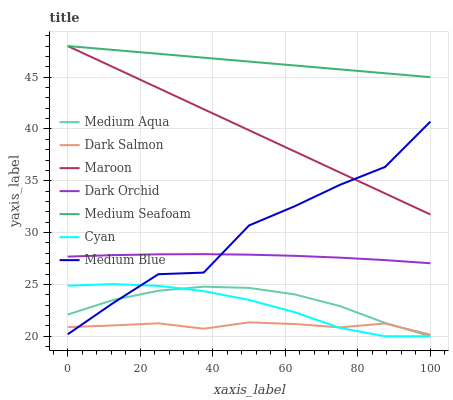Does Dark Salmon have the minimum area under the curve?
Answer yes or no. Yes. Does Medium Seafoam have the maximum area under the curve?
Answer yes or no. Yes. Does Dark Orchid have the minimum area under the curve?
Answer yes or no. No. Does Dark Orchid have the maximum area under the curve?
Answer yes or no. No. Is Medium Seafoam the smoothest?
Answer yes or no. Yes. Is Medium Blue the roughest?
Answer yes or no. Yes. Is Dark Salmon the smoothest?
Answer yes or no. No. Is Dark Salmon the roughest?
Answer yes or no. No. Does Medium Aqua have the lowest value?
Answer yes or no. Yes. Does Dark Salmon have the lowest value?
Answer yes or no. No. Does Medium Seafoam have the highest value?
Answer yes or no. Yes. Does Dark Orchid have the highest value?
Answer yes or no. No. Is Cyan less than Dark Orchid?
Answer yes or no. Yes. Is Dark Orchid greater than Cyan?
Answer yes or no. Yes. Does Medium Blue intersect Dark Orchid?
Answer yes or no. Yes. Is Medium Blue less than Dark Orchid?
Answer yes or no. No. Is Medium Blue greater than Dark Orchid?
Answer yes or no. No. Does Cyan intersect Dark Orchid?
Answer yes or no. No. 